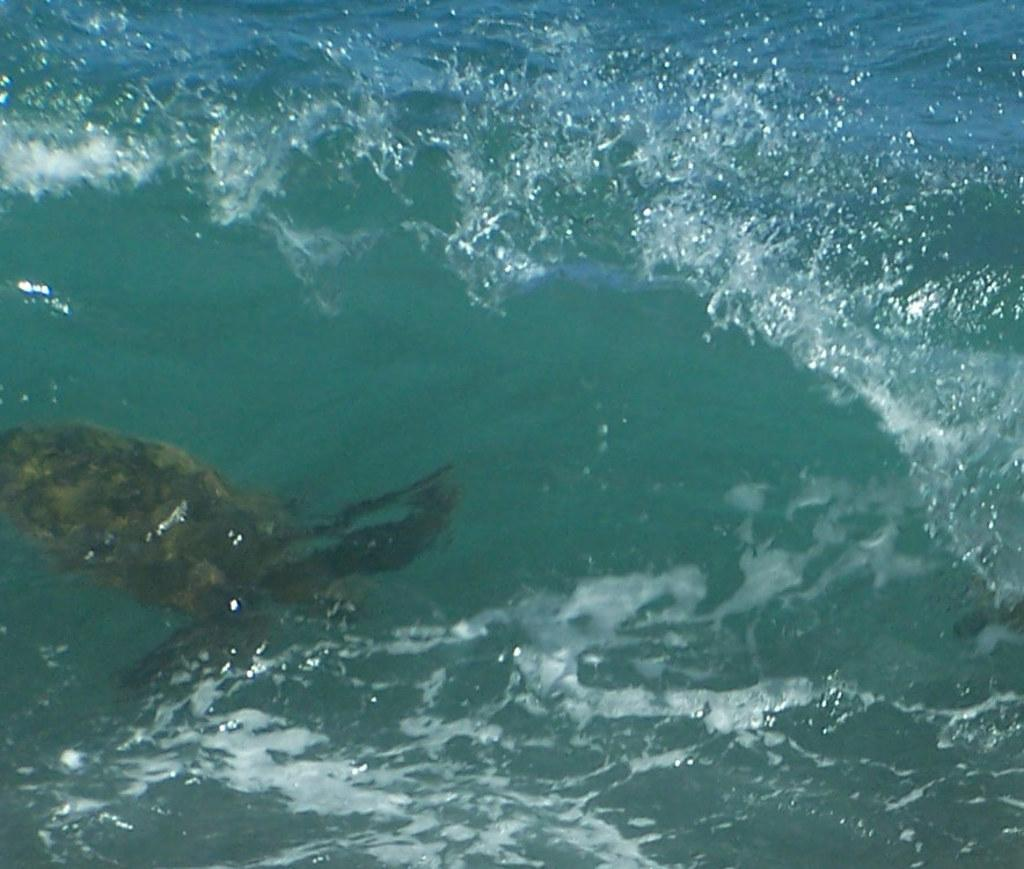What is the primary element visible in the image? There is water in the image. What type of creature can be seen in the water? There is a water animal in the water. How many trucks can be seen driving through the water in the image? There are no trucks visible in the image; it features water and a water animal. What type of creature is crawling on the water's surface in the image? There is no creature crawling on the water's surface in the image; it only features a water animal within the water. 